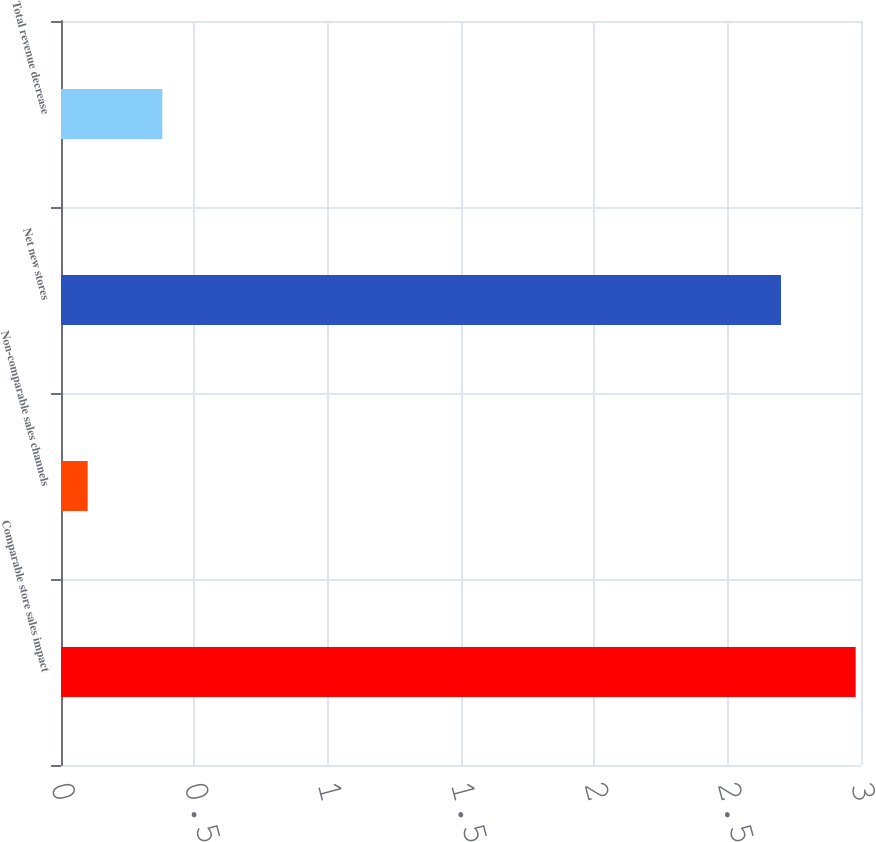Convert chart. <chart><loc_0><loc_0><loc_500><loc_500><bar_chart><fcel>Comparable store sales impact<fcel>Non-comparable sales channels<fcel>Net new stores<fcel>Total revenue decrease<nl><fcel>2.98<fcel>0.1<fcel>2.7<fcel>0.38<nl></chart> 